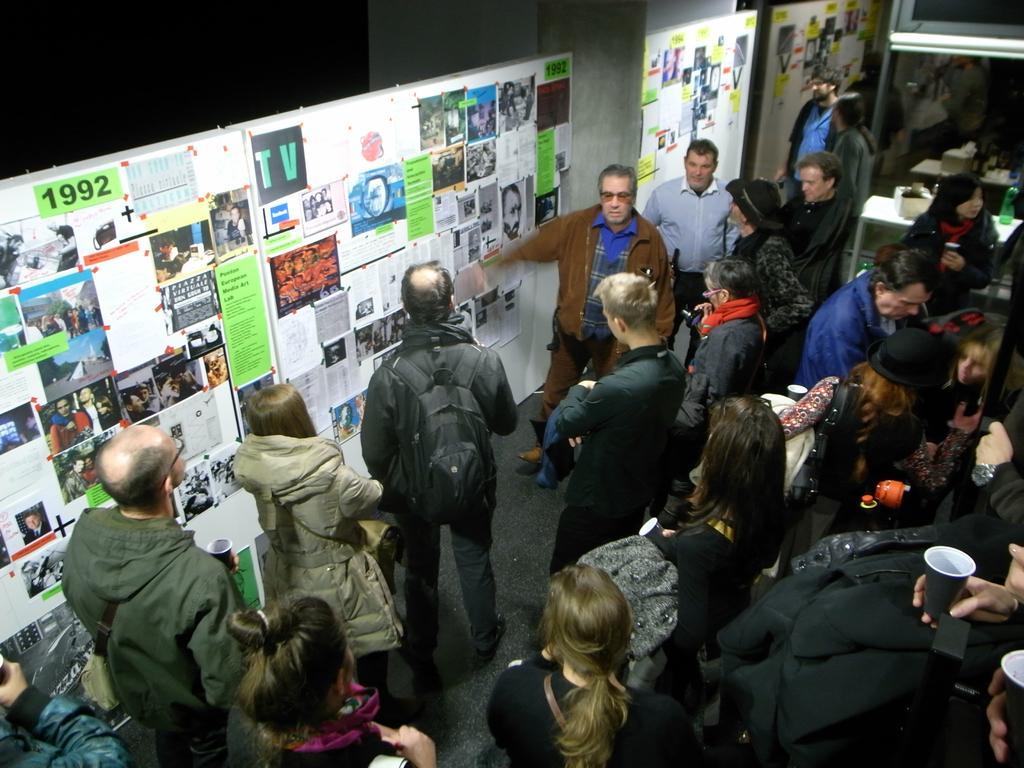Can you describe this image briefly? In this image in the middle there are many people. On the left there is a man, he wears a jacket, in front of him there is a woman, she wears a jacket. In the middle there is a man, he wears a brown color jacket. At the top there are many boards, posters, papers. On the right there are some people, tables, bottles and lights. 